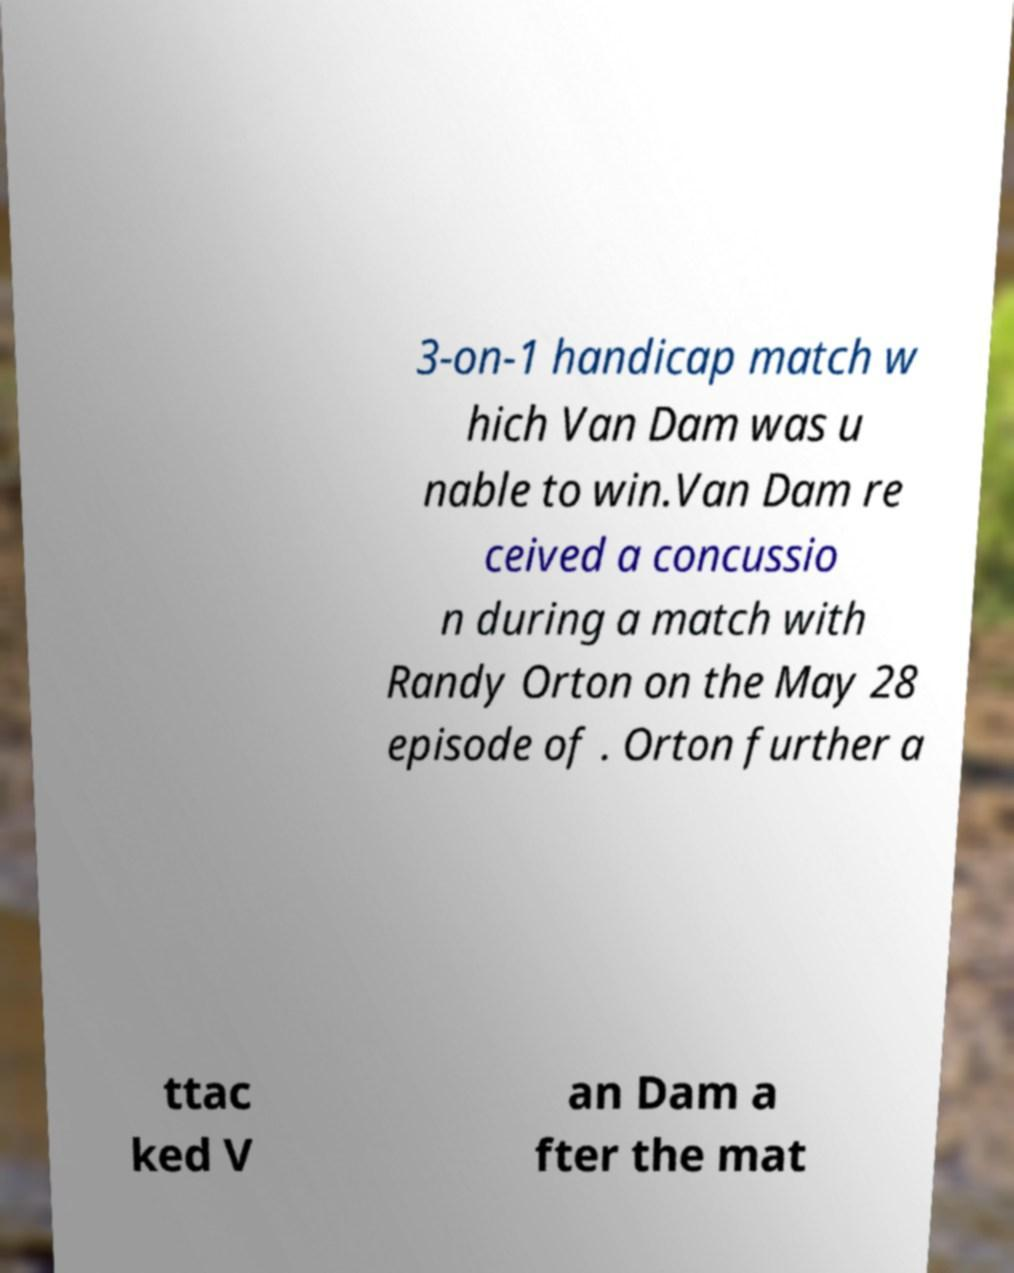Can you accurately transcribe the text from the provided image for me? 3-on-1 handicap match w hich Van Dam was u nable to win.Van Dam re ceived a concussio n during a match with Randy Orton on the May 28 episode of . Orton further a ttac ked V an Dam a fter the mat 